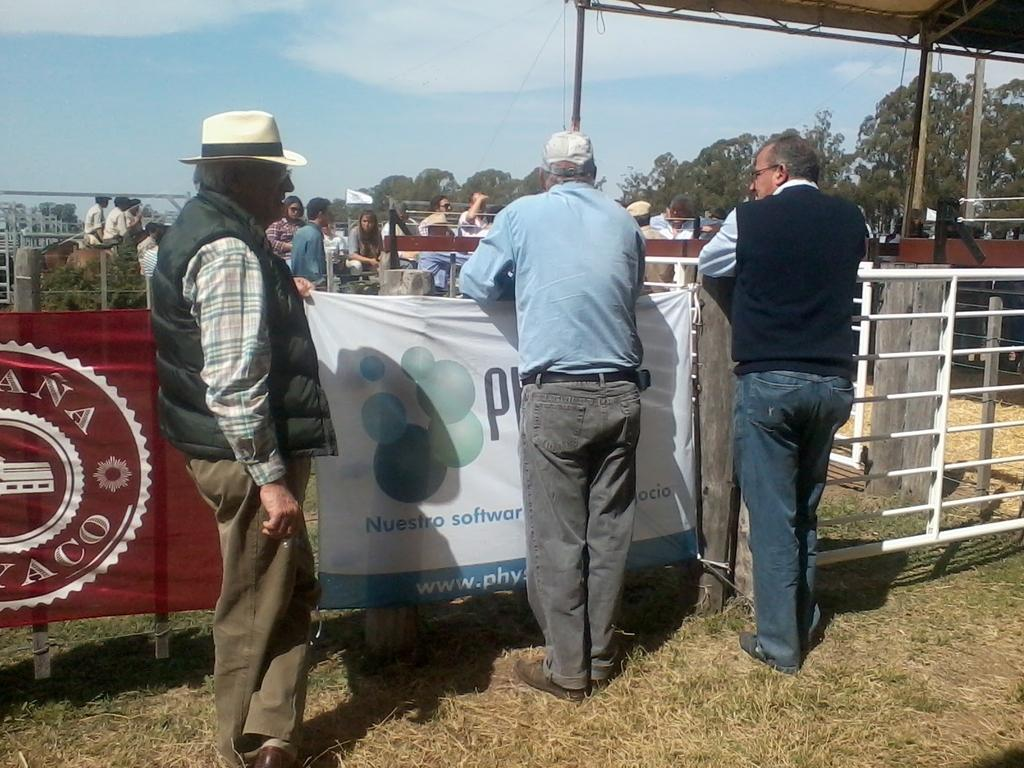What are the people in the image doing? The people in the image are standing. What activity can be seen in the background of the image? There are people riding horses in the background of the image. What type of vegetation is visible in the image? There are trees visible in the image. What is the condition of the sky in the image? The sky is clear in the image. What type of drop can be seen falling from the sky in the image? There is no drop falling from the sky in the image; the sky is clear. Can you tell me the name of the mother of the person riding the horse in the image? There is no information about the riders' mothers in the image. 